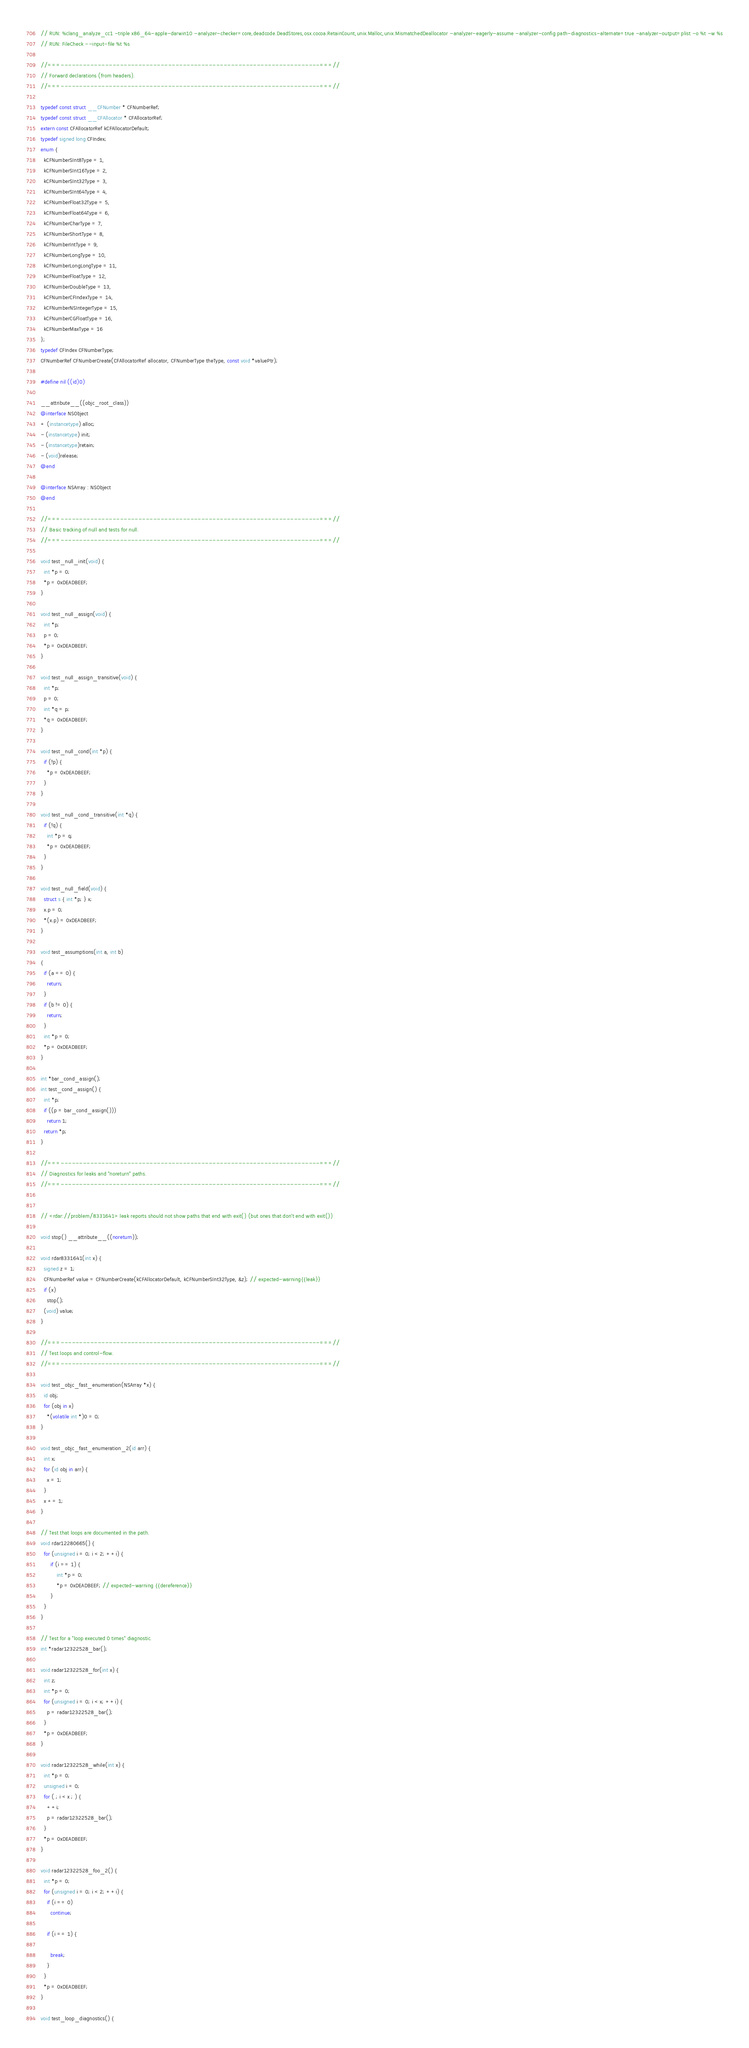<code> <loc_0><loc_0><loc_500><loc_500><_ObjectiveC_>// RUN: %clang_analyze_cc1 -triple x86_64-apple-darwin10 -analyzer-checker=core,deadcode.DeadStores,osx.cocoa.RetainCount,unix.Malloc,unix.MismatchedDeallocator -analyzer-eagerly-assume -analyzer-config path-diagnostics-alternate=true -analyzer-output=plist -o %t -w %s
// RUN: FileCheck --input-file %t %s

//===----------------------------------------------------------------------===//
// Forward declarations (from headers).
//===----------------------------------------------------------------------===//

typedef const struct __CFNumber * CFNumberRef;
typedef const struct __CFAllocator * CFAllocatorRef;
extern const CFAllocatorRef kCFAllocatorDefault;
typedef signed long CFIndex;
enum {
  kCFNumberSInt8Type = 1,
  kCFNumberSInt16Type = 2,
  kCFNumberSInt32Type = 3,
  kCFNumberSInt64Type = 4,
  kCFNumberFloat32Type = 5,
  kCFNumberFloat64Type = 6,
  kCFNumberCharType = 7,
  kCFNumberShortType = 8,
  kCFNumberIntType = 9,
  kCFNumberLongType = 10,
  kCFNumberLongLongType = 11,
  kCFNumberFloatType = 12,
  kCFNumberDoubleType = 13,
  kCFNumberCFIndexType = 14,
  kCFNumberNSIntegerType = 15,
  kCFNumberCGFloatType = 16,
  kCFNumberMaxType = 16
};
typedef CFIndex CFNumberType;
CFNumberRef CFNumberCreate(CFAllocatorRef allocator, CFNumberType theType, const void *valuePtr);

#define nil ((id)0)

__attribute__((objc_root_class))
@interface NSObject
+ (instancetype) alloc;
- (instancetype) init;
- (instancetype)retain;
- (void)release;
@end

@interface NSArray : NSObject
@end

//===----------------------------------------------------------------------===//
// Basic tracking of null and tests for null.
//===----------------------------------------------------------------------===//

void test_null_init(void) {
  int *p = 0;
  *p = 0xDEADBEEF;
}

void test_null_assign(void) {
  int *p;
  p = 0;
  *p = 0xDEADBEEF;
}

void test_null_assign_transitive(void) {
  int *p;
  p = 0;
  int *q = p;
  *q = 0xDEADBEEF;
}

void test_null_cond(int *p) {
  if (!p) {
    *p = 0xDEADBEEF;
  }
}

void test_null_cond_transitive(int *q) {
  if (!q) {
    int *p = q;
    *p = 0xDEADBEEF;
  }
}

void test_null_field(void) {
  struct s { int *p; } x;
  x.p = 0;
  *(x.p) = 0xDEADBEEF;
}

void test_assumptions(int a, int b)
{
  if (a == 0) {
    return;
  }
  if (b != 0) {
    return;
  }
  int *p = 0;
  *p = 0xDEADBEEF;
}

int *bar_cond_assign();
int test_cond_assign() {
  int *p;
  if ((p = bar_cond_assign()))
    return 1;
  return *p;
}

//===----------------------------------------------------------------------===//
// Diagnostics for leaks and "noreturn" paths.
//===----------------------------------------------------------------------===//


// <rdar://problem/8331641> leak reports should not show paths that end with exit() (but ones that don't end with exit())

void stop() __attribute__((noreturn));

void rdar8331641(int x) {
  signed z = 1;
  CFNumberRef value = CFNumberCreate(kCFAllocatorDefault, kCFNumberSInt32Type, &z); // expected-warning{{leak}}
  if (x)
    stop();
  (void) value;
}

//===----------------------------------------------------------------------===//
// Test loops and control-flow.
//===----------------------------------------------------------------------===//

void test_objc_fast_enumeration(NSArray *x) {
  id obj;
  for (obj in x)
    *(volatile int *)0 = 0;
}

void test_objc_fast_enumeration_2(id arr) {
  int x;
  for (id obj in arr) {
    x = 1;
  }
  x += 1;
}

// Test that loops are documented in the path.
void rdar12280665() {
  for (unsigned i = 0; i < 2; ++i) {
	  if (i == 1) {
		  int *p = 0;
		  *p = 0xDEADBEEF; // expected-warning {{dereference}}
	  }
  }
}

// Test for a "loop executed 0 times" diagnostic.
int *radar12322528_bar();

void radar12322528_for(int x) {
  int z;
  int *p = 0;
  for (unsigned i = 0; i < x; ++i) {
    p = radar12322528_bar();
  }
  *p = 0xDEADBEEF;
}

void radar12322528_while(int x) {
  int *p = 0;
  unsigned i = 0;
  for ( ; i < x ; ) {
    ++i;
    p = radar12322528_bar();
  }
  *p = 0xDEADBEEF;
}

void radar12322528_foo_2() {
  int *p = 0;
  for (unsigned i = 0; i < 2; ++i) {
    if (i == 0)
      continue;

    if (i == 1) {

      break;
    }
  }
  *p = 0xDEADBEEF;
}

void test_loop_diagnostics() {</code> 